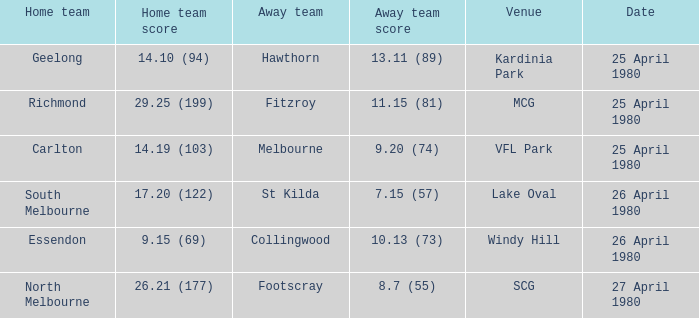Parse the table in full. {'header': ['Home team', 'Home team score', 'Away team', 'Away team score', 'Venue', 'Date'], 'rows': [['Geelong', '14.10 (94)', 'Hawthorn', '13.11 (89)', 'Kardinia Park', '25 April 1980'], ['Richmond', '29.25 (199)', 'Fitzroy', '11.15 (81)', 'MCG', '25 April 1980'], ['Carlton', '14.19 (103)', 'Melbourne', '9.20 (74)', 'VFL Park', '25 April 1980'], ['South Melbourne', '17.20 (122)', 'St Kilda', '7.15 (57)', 'Lake Oval', '26 April 1980'], ['Essendon', '9.15 (69)', 'Collingwood', '10.13 (73)', 'Windy Hill', '26 April 1980'], ['North Melbourne', '26.21 (177)', 'Footscray', '8.7 (55)', 'SCG', '27 April 1980']]} What was the minimum number of spectators at mcg? 44401.0. 